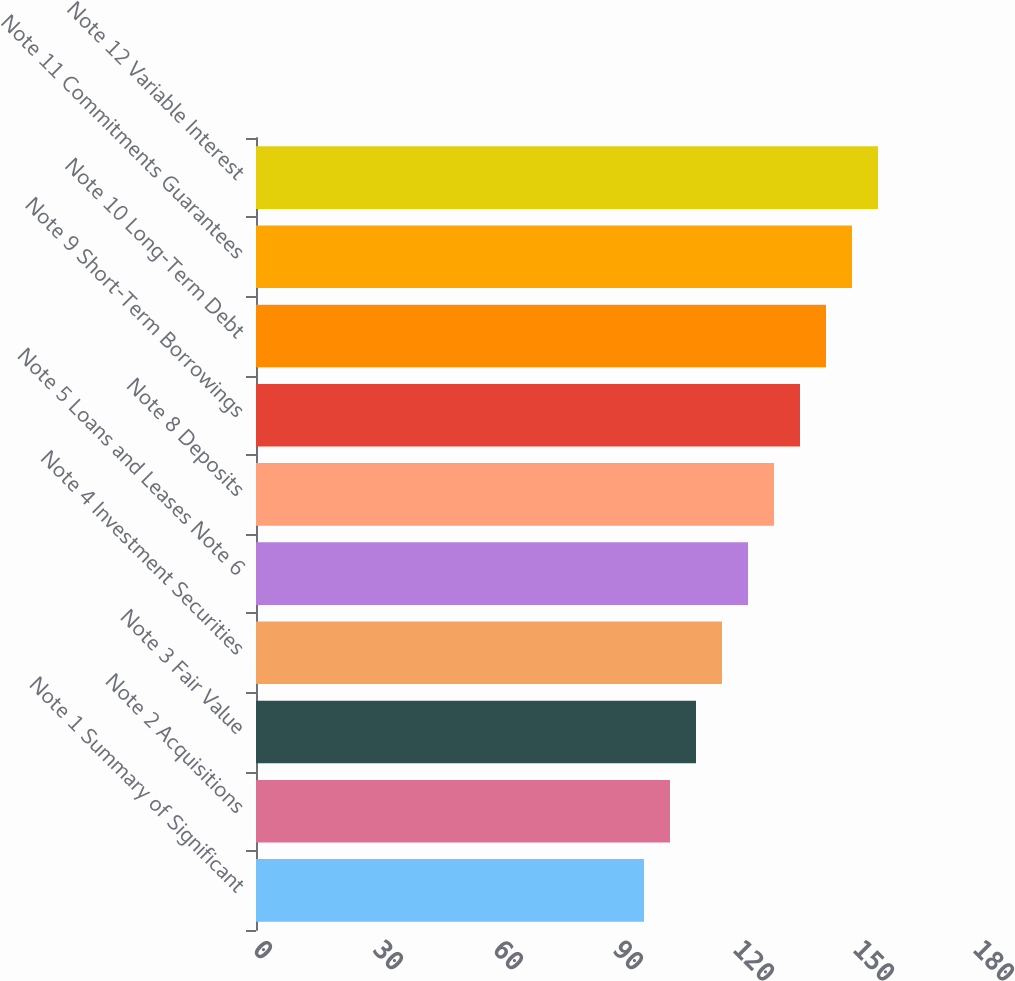Convert chart. <chart><loc_0><loc_0><loc_500><loc_500><bar_chart><fcel>Note 1 Summary of Significant<fcel>Note 2 Acquisitions<fcel>Note 3 Fair Value<fcel>Note 4 Investment Securities<fcel>Note 5 Loans and Leases Note 6<fcel>Note 8 Deposits<fcel>Note 9 Short-Term Borrowings<fcel>Note 10 Long-Term Debt<fcel>Note 11 Commitments Guarantees<fcel>Note 12 Variable Interest<nl><fcel>97<fcel>103.5<fcel>110<fcel>116.5<fcel>123<fcel>129.5<fcel>136<fcel>142.5<fcel>149<fcel>155.5<nl></chart> 